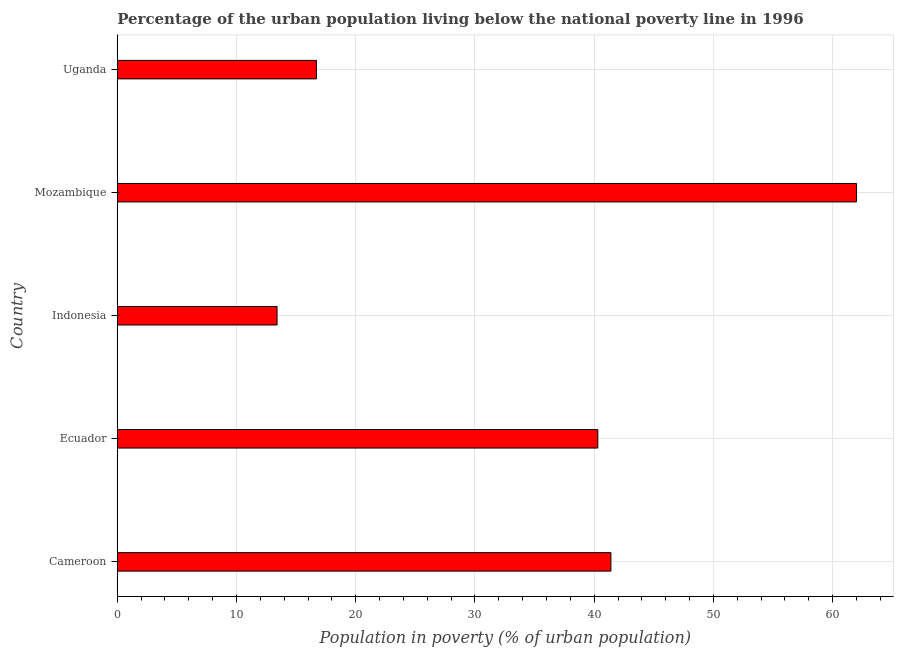What is the title of the graph?
Offer a very short reply. Percentage of the urban population living below the national poverty line in 1996. What is the label or title of the X-axis?
Keep it short and to the point. Population in poverty (% of urban population). In which country was the percentage of urban population living below poverty line maximum?
Offer a terse response. Mozambique. In which country was the percentage of urban population living below poverty line minimum?
Ensure brevity in your answer.  Indonesia. What is the sum of the percentage of urban population living below poverty line?
Offer a terse response. 173.8. What is the difference between the percentage of urban population living below poverty line in Ecuador and Indonesia?
Keep it short and to the point. 26.9. What is the average percentage of urban population living below poverty line per country?
Offer a terse response. 34.76. What is the median percentage of urban population living below poverty line?
Offer a terse response. 40.3. What is the ratio of the percentage of urban population living below poverty line in Ecuador to that in Indonesia?
Keep it short and to the point. 3.01. Is the percentage of urban population living below poverty line in Ecuador less than that in Mozambique?
Your answer should be very brief. Yes. Is the difference between the percentage of urban population living below poverty line in Cameroon and Indonesia greater than the difference between any two countries?
Your response must be concise. No. What is the difference between the highest and the second highest percentage of urban population living below poverty line?
Provide a succinct answer. 20.6. Is the sum of the percentage of urban population living below poverty line in Mozambique and Uganda greater than the maximum percentage of urban population living below poverty line across all countries?
Offer a terse response. Yes. What is the difference between the highest and the lowest percentage of urban population living below poverty line?
Your answer should be very brief. 48.6. How many countries are there in the graph?
Your answer should be very brief. 5. What is the difference between two consecutive major ticks on the X-axis?
Provide a short and direct response. 10. What is the Population in poverty (% of urban population) in Cameroon?
Offer a terse response. 41.4. What is the Population in poverty (% of urban population) of Ecuador?
Your answer should be compact. 40.3. What is the Population in poverty (% of urban population) of Indonesia?
Your answer should be compact. 13.4. What is the Population in poverty (% of urban population) in Uganda?
Make the answer very short. 16.7. What is the difference between the Population in poverty (% of urban population) in Cameroon and Ecuador?
Provide a short and direct response. 1.1. What is the difference between the Population in poverty (% of urban population) in Cameroon and Mozambique?
Your answer should be very brief. -20.6. What is the difference between the Population in poverty (% of urban population) in Cameroon and Uganda?
Give a very brief answer. 24.7. What is the difference between the Population in poverty (% of urban population) in Ecuador and Indonesia?
Your answer should be compact. 26.9. What is the difference between the Population in poverty (% of urban population) in Ecuador and Mozambique?
Your answer should be compact. -21.7. What is the difference between the Population in poverty (% of urban population) in Ecuador and Uganda?
Your response must be concise. 23.6. What is the difference between the Population in poverty (% of urban population) in Indonesia and Mozambique?
Give a very brief answer. -48.6. What is the difference between the Population in poverty (% of urban population) in Indonesia and Uganda?
Ensure brevity in your answer.  -3.3. What is the difference between the Population in poverty (% of urban population) in Mozambique and Uganda?
Your response must be concise. 45.3. What is the ratio of the Population in poverty (% of urban population) in Cameroon to that in Indonesia?
Provide a succinct answer. 3.09. What is the ratio of the Population in poverty (% of urban population) in Cameroon to that in Mozambique?
Your response must be concise. 0.67. What is the ratio of the Population in poverty (% of urban population) in Cameroon to that in Uganda?
Make the answer very short. 2.48. What is the ratio of the Population in poverty (% of urban population) in Ecuador to that in Indonesia?
Offer a terse response. 3.01. What is the ratio of the Population in poverty (% of urban population) in Ecuador to that in Mozambique?
Your answer should be compact. 0.65. What is the ratio of the Population in poverty (% of urban population) in Ecuador to that in Uganda?
Your response must be concise. 2.41. What is the ratio of the Population in poverty (% of urban population) in Indonesia to that in Mozambique?
Offer a terse response. 0.22. What is the ratio of the Population in poverty (% of urban population) in Indonesia to that in Uganda?
Ensure brevity in your answer.  0.8. What is the ratio of the Population in poverty (% of urban population) in Mozambique to that in Uganda?
Ensure brevity in your answer.  3.71. 